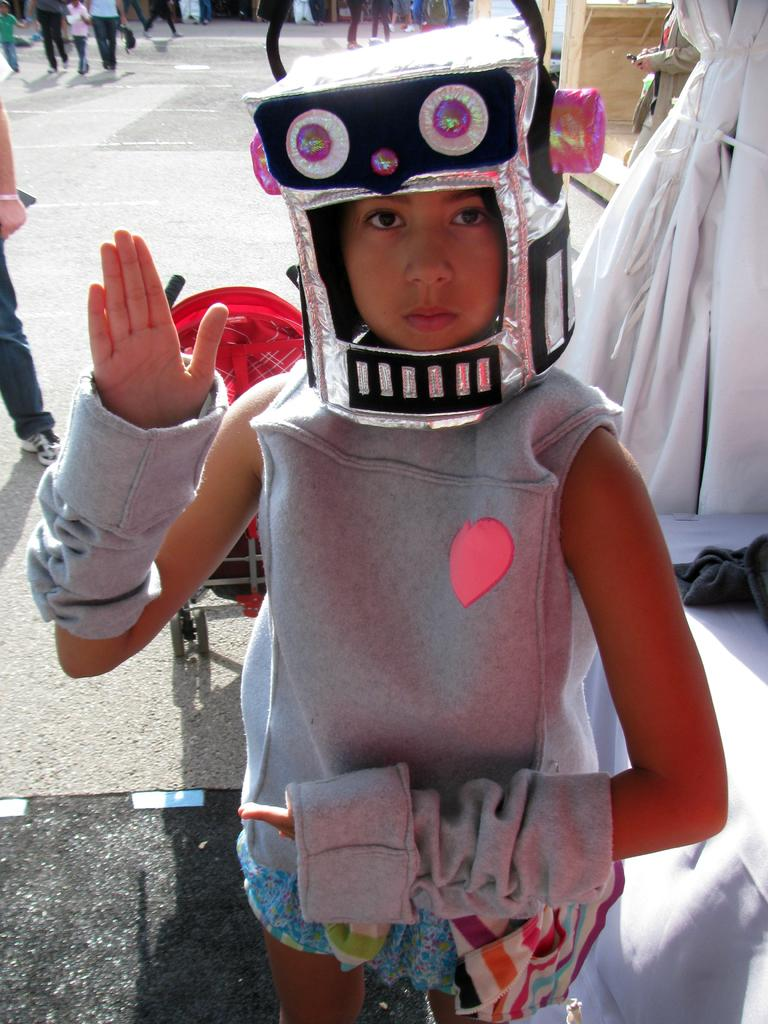What is the main subject of the image? The main subject of the image is a child. What is the child wearing? The child is wearing clothes and a robot mask. What is the setting of the image? There is a footpath in the image. Are there any other people in the image? Yes, there are other people in the image. What are the other people wearing? The other people are wearing clothes and shoes. What are the other people doing? The other people are walking. How many fish can be seen swimming in the image? There are no fish present in the image. What type of tree is visible in the image? There is no tree visible in the image. 